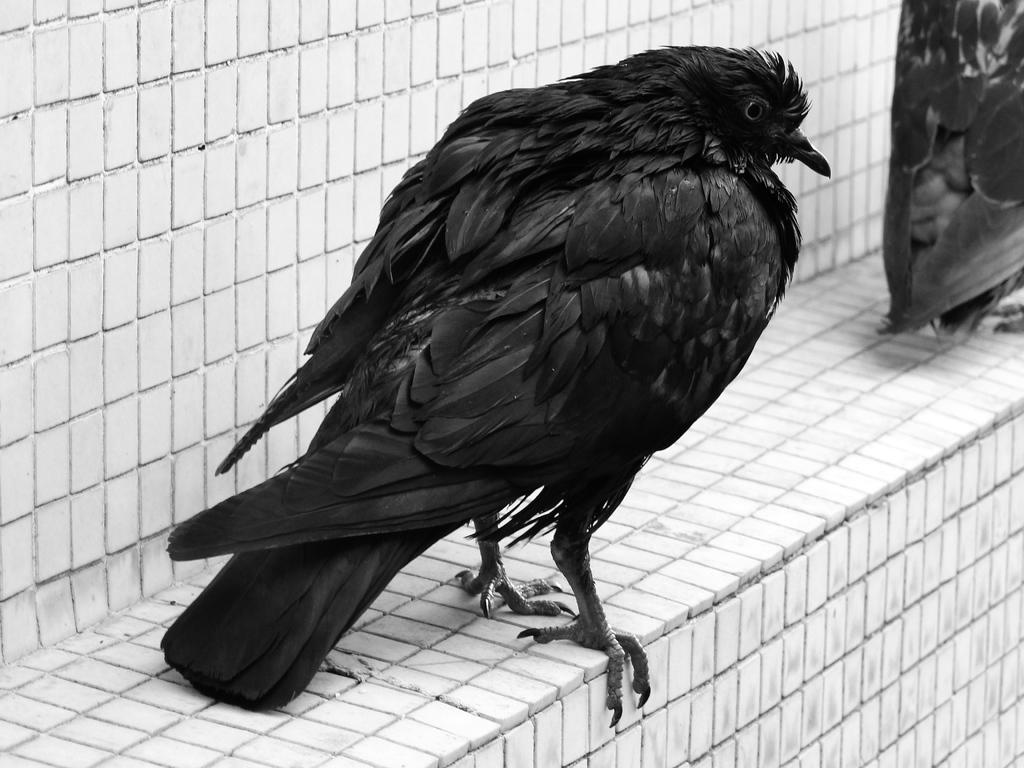What type of animals can be seen in the image? There are birds in the image. Where are the birds located in the image? The birds are on a wall. What riddle is the bird trying to solve in the image? There is no indication in the image that the bird is trying to solve a riddle. 